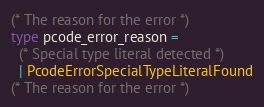<code> <loc_0><loc_0><loc_500><loc_500><_OCaml_>(* The reason for the error *)
type pcode_error_reason =
  (* Special type literal detected *)
  | PcodeErrorSpecialTypeLiteralFound
(* The reason for the error *)</code> 